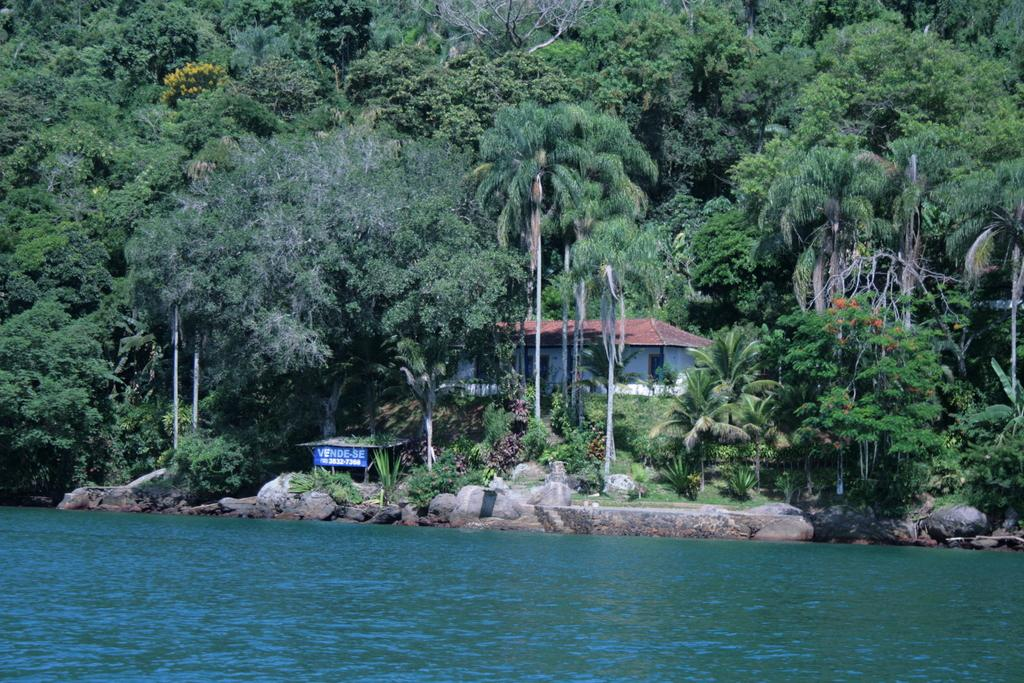What is present in the image that represents a natural element? There is water visible in the image, which represents a natural element. What type of objects can be seen in the image that are not natural? There are stones and a banner visible in the image, which are not natural elements. What type of structure is present in the image? There is a house in the image. What type of vegetation is present in the image? There are trees in the image. What type of cheese is being served on the sidewalk in the image? There is no cheese or sidewalk present in the image. What is the end result of the event depicted in the image? The image does not depict an event, so there is no end result to describe. 